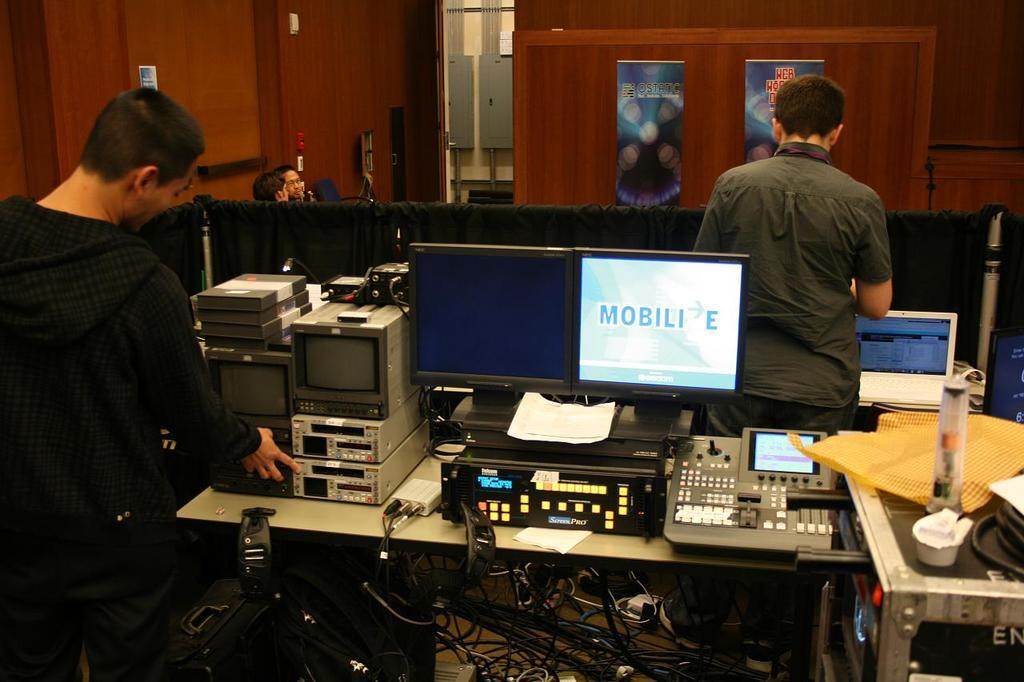Provide a one-sentence caption for the provided image. Man working on a computer with a screen that says "Mobilie". 